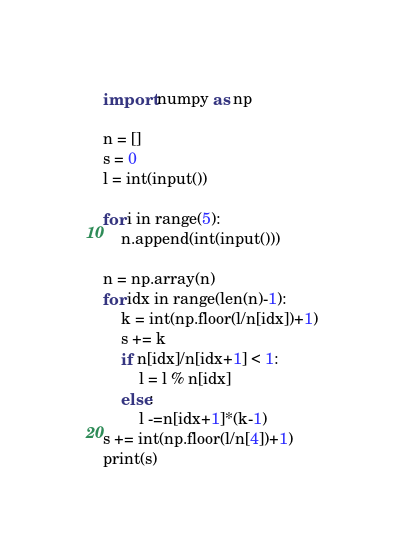<code> <loc_0><loc_0><loc_500><loc_500><_Python_>import numpy as np

n = []
s = 0
l = int(input())

for i in range(5):
    n.append(int(input()))

n = np.array(n)
for idx in range(len(n)-1):
    k = int(np.floor(l/n[idx])+1)
    s += k
    if n[idx]/n[idx+1] < 1:
        l = l % n[idx]
    else:
        l -=n[idx+1]*(k-1)
s += int(np.floor(l/n[4])+1)
print(s)</code> 